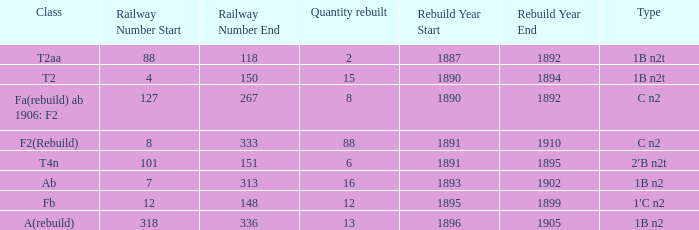What was the Rebuildjahr(e) for the T2AA class? 1887–1892. 